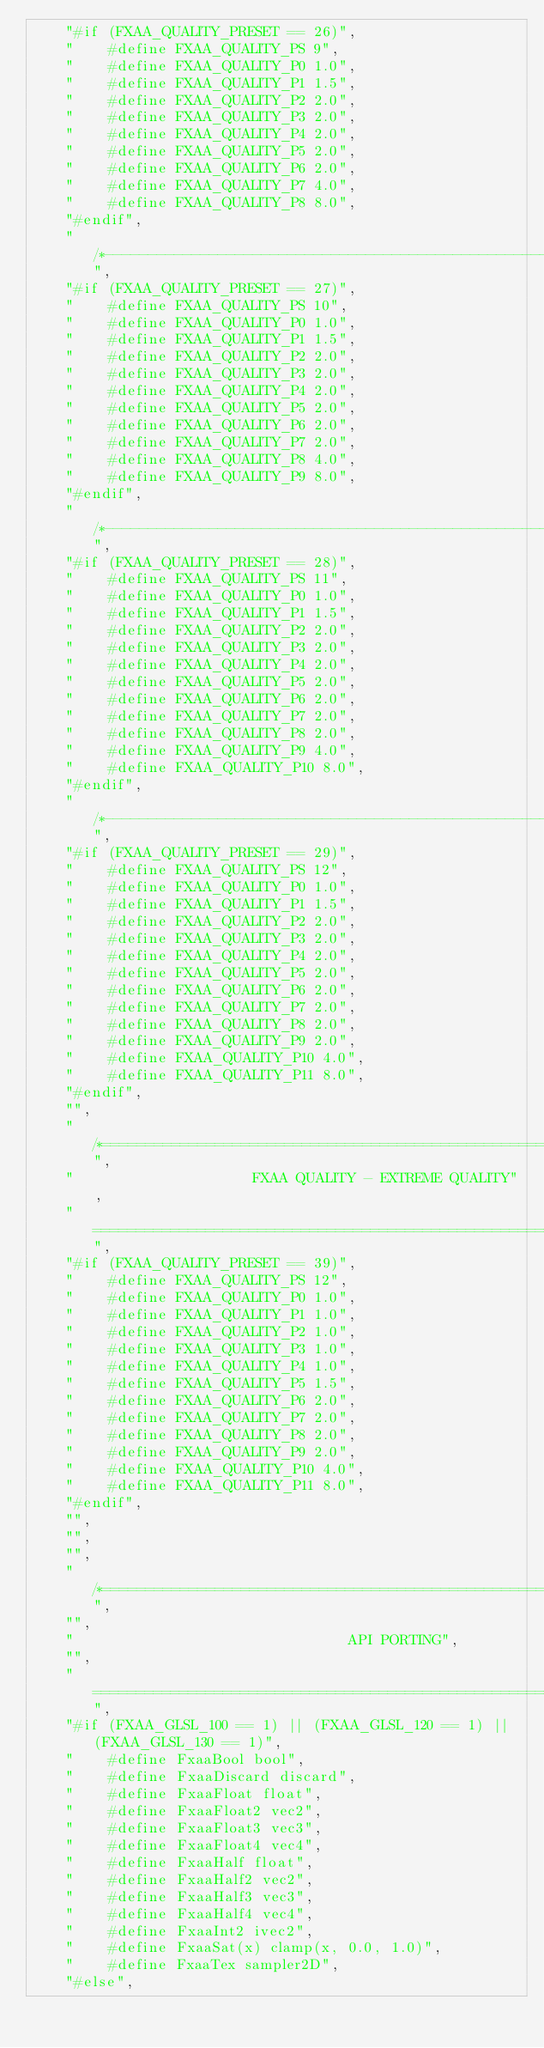Convert code to text. <code><loc_0><loc_0><loc_500><loc_500><_JavaScript_>		"#if (FXAA_QUALITY_PRESET == 26)",
		"    #define FXAA_QUALITY_PS 9",
		"    #define FXAA_QUALITY_P0 1.0",
		"    #define FXAA_QUALITY_P1 1.5",
		"    #define FXAA_QUALITY_P2 2.0",
		"    #define FXAA_QUALITY_P3 2.0",
		"    #define FXAA_QUALITY_P4 2.0",
		"    #define FXAA_QUALITY_P5 2.0",
		"    #define FXAA_QUALITY_P6 2.0",
		"    #define FXAA_QUALITY_P7 4.0",
		"    #define FXAA_QUALITY_P8 8.0",
		"#endif",
		"/*--------------------------------------------------------------------------*/",
		"#if (FXAA_QUALITY_PRESET == 27)",
		"    #define FXAA_QUALITY_PS 10",
		"    #define FXAA_QUALITY_P0 1.0",
		"    #define FXAA_QUALITY_P1 1.5",
		"    #define FXAA_QUALITY_P2 2.0",
		"    #define FXAA_QUALITY_P3 2.0",
		"    #define FXAA_QUALITY_P4 2.0",
		"    #define FXAA_QUALITY_P5 2.0",
		"    #define FXAA_QUALITY_P6 2.0",
		"    #define FXAA_QUALITY_P7 2.0",
		"    #define FXAA_QUALITY_P8 4.0",
		"    #define FXAA_QUALITY_P9 8.0",
		"#endif",
		"/*--------------------------------------------------------------------------*/",
		"#if (FXAA_QUALITY_PRESET == 28)",
		"    #define FXAA_QUALITY_PS 11",
		"    #define FXAA_QUALITY_P0 1.0",
		"    #define FXAA_QUALITY_P1 1.5",
		"    #define FXAA_QUALITY_P2 2.0",
		"    #define FXAA_QUALITY_P3 2.0",
		"    #define FXAA_QUALITY_P4 2.0",
		"    #define FXAA_QUALITY_P5 2.0",
		"    #define FXAA_QUALITY_P6 2.0",
		"    #define FXAA_QUALITY_P7 2.0",
		"    #define FXAA_QUALITY_P8 2.0",
		"    #define FXAA_QUALITY_P9 4.0",
		"    #define FXAA_QUALITY_P10 8.0",
		"#endif",
		"/*--------------------------------------------------------------------------*/",
		"#if (FXAA_QUALITY_PRESET == 29)",
		"    #define FXAA_QUALITY_PS 12",
		"    #define FXAA_QUALITY_P0 1.0",
		"    #define FXAA_QUALITY_P1 1.5",
		"    #define FXAA_QUALITY_P2 2.0",
		"    #define FXAA_QUALITY_P3 2.0",
		"    #define FXAA_QUALITY_P4 2.0",
		"    #define FXAA_QUALITY_P5 2.0",
		"    #define FXAA_QUALITY_P6 2.0",
		"    #define FXAA_QUALITY_P7 2.0",
		"    #define FXAA_QUALITY_P8 2.0",
		"    #define FXAA_QUALITY_P9 2.0",
		"    #define FXAA_QUALITY_P10 4.0",
		"    #define FXAA_QUALITY_P11 8.0",
		"#endif",
		"",
		"/*============================================================================",
		"                     FXAA QUALITY - EXTREME QUALITY",
		"============================================================================*/",
		"#if (FXAA_QUALITY_PRESET == 39)",
		"    #define FXAA_QUALITY_PS 12",
		"    #define FXAA_QUALITY_P0 1.0",
		"    #define FXAA_QUALITY_P1 1.0",
		"    #define FXAA_QUALITY_P2 1.0",
		"    #define FXAA_QUALITY_P3 1.0",
		"    #define FXAA_QUALITY_P4 1.0",
		"    #define FXAA_QUALITY_P5 1.5",
		"    #define FXAA_QUALITY_P6 2.0",
		"    #define FXAA_QUALITY_P7 2.0",
		"    #define FXAA_QUALITY_P8 2.0",
		"    #define FXAA_QUALITY_P9 2.0",
		"    #define FXAA_QUALITY_P10 4.0",
		"    #define FXAA_QUALITY_P11 8.0",
		"#endif",
		"",
		"",
		"",
		"/*============================================================================",
		"",
		"                                API PORTING",
		"",
		"============================================================================*/",
		"#if (FXAA_GLSL_100 == 1) || (FXAA_GLSL_120 == 1) || (FXAA_GLSL_130 == 1)",
		"    #define FxaaBool bool",
		"    #define FxaaDiscard discard",
		"    #define FxaaFloat float",
		"    #define FxaaFloat2 vec2",
		"    #define FxaaFloat3 vec3",
		"    #define FxaaFloat4 vec4",
		"    #define FxaaHalf float",
		"    #define FxaaHalf2 vec2",
		"    #define FxaaHalf3 vec3",
		"    #define FxaaHalf4 vec4",
		"    #define FxaaInt2 ivec2",
		"    #define FxaaSat(x) clamp(x, 0.0, 1.0)",
		"    #define FxaaTex sampler2D",
		"#else",</code> 